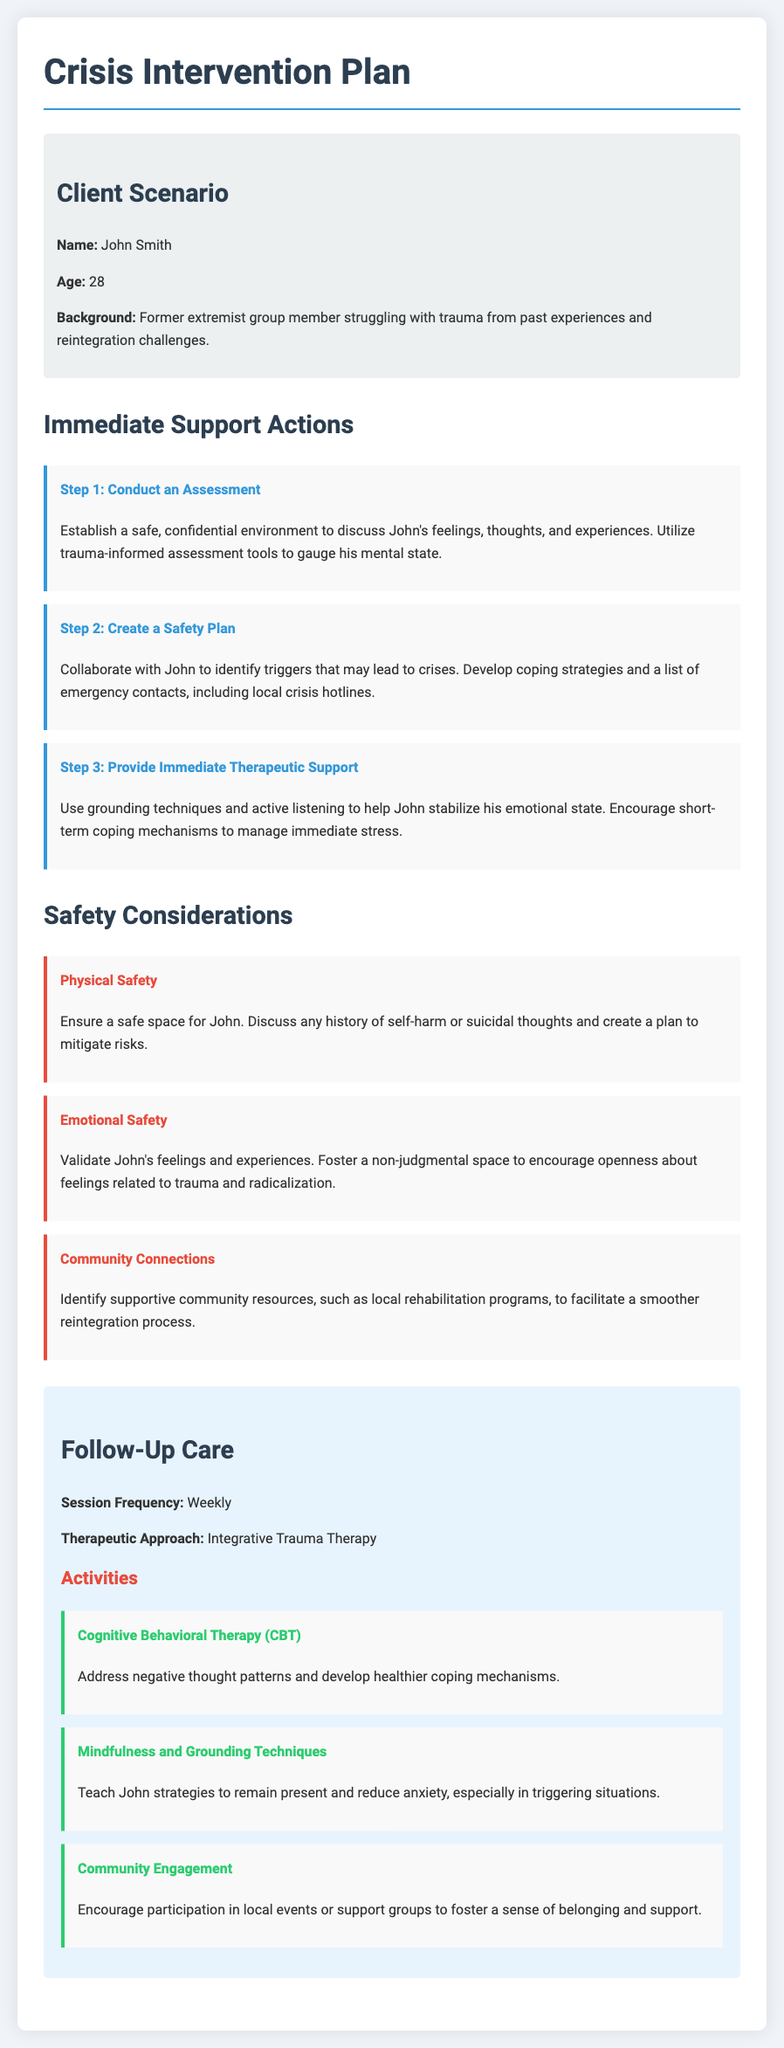What is the client’s name? The client's name is mentioned at the beginning of the document under the client scenario section.
Answer: John Smith What is the client's age? The document specifies the age of the client in the client info section.
Answer: 28 What therapeutic approach is suggested for follow-up care? The therapeutic approach is clearly stated in the follow-up care section.
Answer: Integrative Trauma Therapy How often should follow-up sessions occur? The frequency of sessions is detailed under follow-up care.
Answer: Weekly What is one of the immediate support actions? The document lists immediate support actions, one of which is an assessment.
Answer: Conduct an Assessment What is a safety consideration related to emotional safety? Emotional safety considerations are detailed in the safety consideration section.
Answer: Validate John's feelings How many immediate support actions are listed? The document lists the immediate support actions and their count can be derived from that section.
Answer: Three What activity focuses on helping John reduce anxiety? The activities section contains various activities, one of which specifically addresses this.
Answer: Mindfulness and Grounding Techniques What is the title of the document? The title of the document is indicated at the top of the rendered document.
Answer: Crisis Intervention Plan - John Smith 